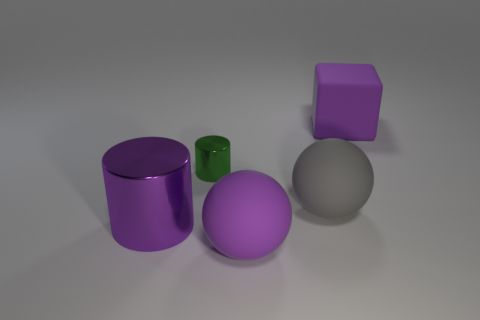Are there fewer big cyan shiny cylinders than large rubber cubes?
Offer a terse response. Yes. There is a metal object to the right of the big shiny object; does it have the same color as the large cube?
Keep it short and to the point. No. There is a large purple rubber thing that is to the left of the big object behind the green metal cylinder; how many matte objects are behind it?
Your answer should be very brief. 2. How many purple blocks are to the left of the purple metal cylinder?
Ensure brevity in your answer.  0. There is another thing that is the same shape as the gray thing; what is its color?
Your answer should be very brief. Purple. There is a object that is both on the left side of the large gray rubber ball and behind the big metal cylinder; what material is it?
Your answer should be very brief. Metal. Is the size of the purple matte thing that is in front of the purple rubber block the same as the large purple metal object?
Keep it short and to the point. Yes. What material is the purple sphere?
Your answer should be compact. Rubber. What color is the rubber thing that is in front of the big cylinder?
Provide a short and direct response. Purple. What number of small things are either gray rubber things or yellow things?
Offer a terse response. 0. 